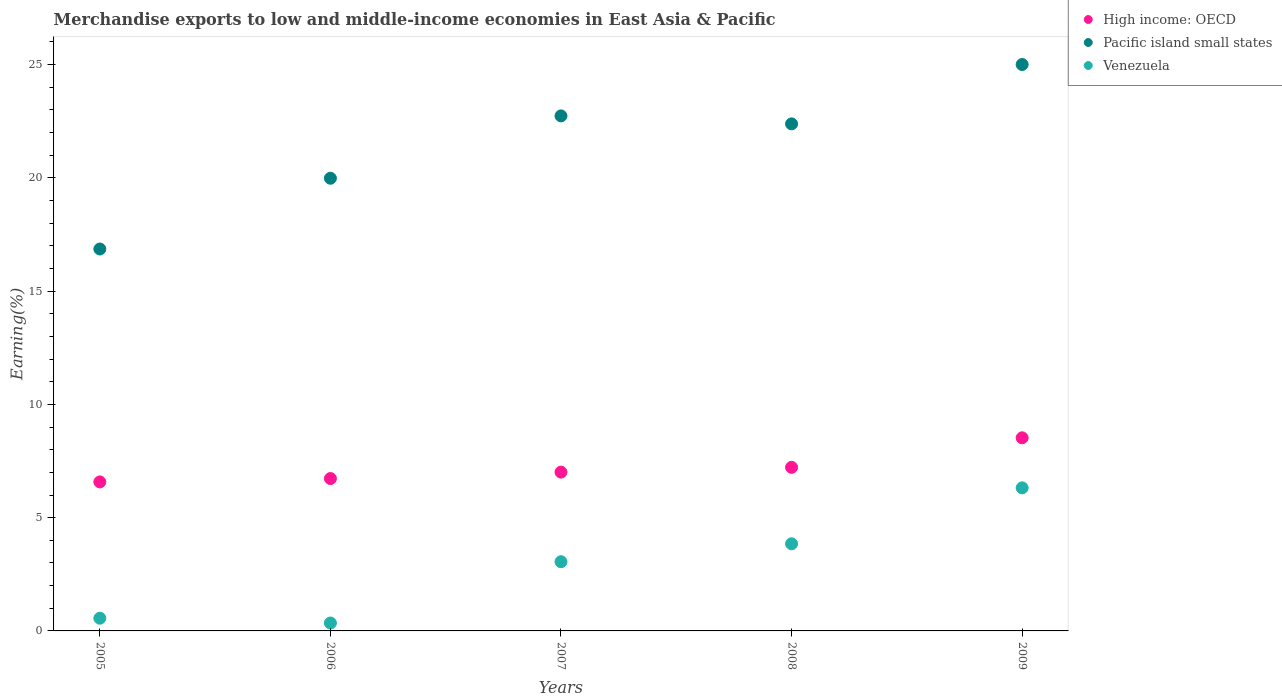Is the number of dotlines equal to the number of legend labels?
Provide a short and direct response. Yes. What is the percentage of amount earned from merchandise exports in Pacific island small states in 2006?
Keep it short and to the point. 19.98. Across all years, what is the maximum percentage of amount earned from merchandise exports in Venezuela?
Offer a very short reply. 6.32. Across all years, what is the minimum percentage of amount earned from merchandise exports in Venezuela?
Provide a short and direct response. 0.35. In which year was the percentage of amount earned from merchandise exports in Pacific island small states minimum?
Give a very brief answer. 2005. What is the total percentage of amount earned from merchandise exports in Pacific island small states in the graph?
Offer a terse response. 106.97. What is the difference between the percentage of amount earned from merchandise exports in High income: OECD in 2005 and that in 2006?
Offer a terse response. -0.15. What is the difference between the percentage of amount earned from merchandise exports in Venezuela in 2006 and the percentage of amount earned from merchandise exports in High income: OECD in 2005?
Provide a succinct answer. -6.23. What is the average percentage of amount earned from merchandise exports in Pacific island small states per year?
Ensure brevity in your answer.  21.39. In the year 2008, what is the difference between the percentage of amount earned from merchandise exports in High income: OECD and percentage of amount earned from merchandise exports in Venezuela?
Your answer should be very brief. 3.38. What is the ratio of the percentage of amount earned from merchandise exports in Pacific island small states in 2007 to that in 2008?
Your answer should be compact. 1.02. Is the difference between the percentage of amount earned from merchandise exports in High income: OECD in 2006 and 2008 greater than the difference between the percentage of amount earned from merchandise exports in Venezuela in 2006 and 2008?
Provide a succinct answer. Yes. What is the difference between the highest and the second highest percentage of amount earned from merchandise exports in Pacific island small states?
Ensure brevity in your answer.  2.27. What is the difference between the highest and the lowest percentage of amount earned from merchandise exports in Venezuela?
Ensure brevity in your answer.  5.97. Is the sum of the percentage of amount earned from merchandise exports in Pacific island small states in 2007 and 2009 greater than the maximum percentage of amount earned from merchandise exports in Venezuela across all years?
Your response must be concise. Yes. Is it the case that in every year, the sum of the percentage of amount earned from merchandise exports in Pacific island small states and percentage of amount earned from merchandise exports in Venezuela  is greater than the percentage of amount earned from merchandise exports in High income: OECD?
Offer a very short reply. Yes. Does the percentage of amount earned from merchandise exports in Pacific island small states monotonically increase over the years?
Ensure brevity in your answer.  No. How many dotlines are there?
Make the answer very short. 3. Are the values on the major ticks of Y-axis written in scientific E-notation?
Your response must be concise. No. Does the graph contain any zero values?
Provide a short and direct response. No. Where does the legend appear in the graph?
Give a very brief answer. Top right. How many legend labels are there?
Your response must be concise. 3. How are the legend labels stacked?
Your answer should be very brief. Vertical. What is the title of the graph?
Your answer should be very brief. Merchandise exports to low and middle-income economies in East Asia & Pacific. What is the label or title of the Y-axis?
Offer a terse response. Earning(%). What is the Earning(%) in High income: OECD in 2005?
Give a very brief answer. 6.58. What is the Earning(%) in Pacific island small states in 2005?
Offer a terse response. 16.86. What is the Earning(%) of Venezuela in 2005?
Ensure brevity in your answer.  0.56. What is the Earning(%) of High income: OECD in 2006?
Your answer should be compact. 6.73. What is the Earning(%) of Pacific island small states in 2006?
Provide a succinct answer. 19.98. What is the Earning(%) of Venezuela in 2006?
Provide a short and direct response. 0.35. What is the Earning(%) of High income: OECD in 2007?
Give a very brief answer. 7.01. What is the Earning(%) in Pacific island small states in 2007?
Keep it short and to the point. 22.74. What is the Earning(%) in Venezuela in 2007?
Your response must be concise. 3.06. What is the Earning(%) in High income: OECD in 2008?
Your response must be concise. 7.22. What is the Earning(%) in Pacific island small states in 2008?
Your answer should be compact. 22.39. What is the Earning(%) of Venezuela in 2008?
Give a very brief answer. 3.85. What is the Earning(%) in High income: OECD in 2009?
Ensure brevity in your answer.  8.53. What is the Earning(%) in Pacific island small states in 2009?
Your answer should be very brief. 25.01. What is the Earning(%) in Venezuela in 2009?
Offer a terse response. 6.32. Across all years, what is the maximum Earning(%) of High income: OECD?
Provide a succinct answer. 8.53. Across all years, what is the maximum Earning(%) of Pacific island small states?
Your response must be concise. 25.01. Across all years, what is the maximum Earning(%) of Venezuela?
Ensure brevity in your answer.  6.32. Across all years, what is the minimum Earning(%) in High income: OECD?
Offer a very short reply. 6.58. Across all years, what is the minimum Earning(%) of Pacific island small states?
Provide a short and direct response. 16.86. Across all years, what is the minimum Earning(%) of Venezuela?
Ensure brevity in your answer.  0.35. What is the total Earning(%) of High income: OECD in the graph?
Offer a terse response. 36.07. What is the total Earning(%) of Pacific island small states in the graph?
Offer a very short reply. 106.97. What is the total Earning(%) in Venezuela in the graph?
Provide a short and direct response. 14.13. What is the difference between the Earning(%) of High income: OECD in 2005 and that in 2006?
Your answer should be compact. -0.15. What is the difference between the Earning(%) in Pacific island small states in 2005 and that in 2006?
Your answer should be very brief. -3.12. What is the difference between the Earning(%) in Venezuela in 2005 and that in 2006?
Ensure brevity in your answer.  0.21. What is the difference between the Earning(%) in High income: OECD in 2005 and that in 2007?
Keep it short and to the point. -0.43. What is the difference between the Earning(%) in Pacific island small states in 2005 and that in 2007?
Provide a succinct answer. -5.88. What is the difference between the Earning(%) in Venezuela in 2005 and that in 2007?
Ensure brevity in your answer.  -2.49. What is the difference between the Earning(%) of High income: OECD in 2005 and that in 2008?
Keep it short and to the point. -0.64. What is the difference between the Earning(%) of Pacific island small states in 2005 and that in 2008?
Your answer should be compact. -5.52. What is the difference between the Earning(%) in Venezuela in 2005 and that in 2008?
Provide a short and direct response. -3.29. What is the difference between the Earning(%) in High income: OECD in 2005 and that in 2009?
Offer a terse response. -1.95. What is the difference between the Earning(%) in Pacific island small states in 2005 and that in 2009?
Ensure brevity in your answer.  -8.14. What is the difference between the Earning(%) of Venezuela in 2005 and that in 2009?
Make the answer very short. -5.75. What is the difference between the Earning(%) of High income: OECD in 2006 and that in 2007?
Make the answer very short. -0.28. What is the difference between the Earning(%) in Pacific island small states in 2006 and that in 2007?
Your answer should be compact. -2.75. What is the difference between the Earning(%) of Venezuela in 2006 and that in 2007?
Your answer should be compact. -2.71. What is the difference between the Earning(%) of High income: OECD in 2006 and that in 2008?
Offer a terse response. -0.5. What is the difference between the Earning(%) of Pacific island small states in 2006 and that in 2008?
Offer a terse response. -2.4. What is the difference between the Earning(%) in Venezuela in 2006 and that in 2008?
Make the answer very short. -3.5. What is the difference between the Earning(%) of High income: OECD in 2006 and that in 2009?
Make the answer very short. -1.8. What is the difference between the Earning(%) of Pacific island small states in 2006 and that in 2009?
Offer a very short reply. -5.02. What is the difference between the Earning(%) in Venezuela in 2006 and that in 2009?
Ensure brevity in your answer.  -5.97. What is the difference between the Earning(%) in High income: OECD in 2007 and that in 2008?
Your answer should be compact. -0.21. What is the difference between the Earning(%) of Pacific island small states in 2007 and that in 2008?
Offer a terse response. 0.35. What is the difference between the Earning(%) of Venezuela in 2007 and that in 2008?
Your answer should be very brief. -0.79. What is the difference between the Earning(%) of High income: OECD in 2007 and that in 2009?
Provide a short and direct response. -1.52. What is the difference between the Earning(%) in Pacific island small states in 2007 and that in 2009?
Make the answer very short. -2.27. What is the difference between the Earning(%) of Venezuela in 2007 and that in 2009?
Your response must be concise. -3.26. What is the difference between the Earning(%) of High income: OECD in 2008 and that in 2009?
Give a very brief answer. -1.3. What is the difference between the Earning(%) in Pacific island small states in 2008 and that in 2009?
Offer a very short reply. -2.62. What is the difference between the Earning(%) of Venezuela in 2008 and that in 2009?
Provide a succinct answer. -2.47. What is the difference between the Earning(%) in High income: OECD in 2005 and the Earning(%) in Pacific island small states in 2006?
Offer a very short reply. -13.41. What is the difference between the Earning(%) in High income: OECD in 2005 and the Earning(%) in Venezuela in 2006?
Keep it short and to the point. 6.23. What is the difference between the Earning(%) in Pacific island small states in 2005 and the Earning(%) in Venezuela in 2006?
Make the answer very short. 16.51. What is the difference between the Earning(%) in High income: OECD in 2005 and the Earning(%) in Pacific island small states in 2007?
Ensure brevity in your answer.  -16.16. What is the difference between the Earning(%) in High income: OECD in 2005 and the Earning(%) in Venezuela in 2007?
Your answer should be compact. 3.52. What is the difference between the Earning(%) in Pacific island small states in 2005 and the Earning(%) in Venezuela in 2007?
Your answer should be compact. 13.81. What is the difference between the Earning(%) in High income: OECD in 2005 and the Earning(%) in Pacific island small states in 2008?
Your response must be concise. -15.81. What is the difference between the Earning(%) of High income: OECD in 2005 and the Earning(%) of Venezuela in 2008?
Provide a succinct answer. 2.73. What is the difference between the Earning(%) in Pacific island small states in 2005 and the Earning(%) in Venezuela in 2008?
Offer a terse response. 13.01. What is the difference between the Earning(%) of High income: OECD in 2005 and the Earning(%) of Pacific island small states in 2009?
Provide a short and direct response. -18.43. What is the difference between the Earning(%) of High income: OECD in 2005 and the Earning(%) of Venezuela in 2009?
Your answer should be very brief. 0.26. What is the difference between the Earning(%) in Pacific island small states in 2005 and the Earning(%) in Venezuela in 2009?
Your answer should be compact. 10.55. What is the difference between the Earning(%) in High income: OECD in 2006 and the Earning(%) in Pacific island small states in 2007?
Give a very brief answer. -16.01. What is the difference between the Earning(%) in High income: OECD in 2006 and the Earning(%) in Venezuela in 2007?
Your answer should be compact. 3.67. What is the difference between the Earning(%) in Pacific island small states in 2006 and the Earning(%) in Venezuela in 2007?
Make the answer very short. 16.93. What is the difference between the Earning(%) in High income: OECD in 2006 and the Earning(%) in Pacific island small states in 2008?
Your answer should be very brief. -15.66. What is the difference between the Earning(%) of High income: OECD in 2006 and the Earning(%) of Venezuela in 2008?
Your response must be concise. 2.88. What is the difference between the Earning(%) of Pacific island small states in 2006 and the Earning(%) of Venezuela in 2008?
Your answer should be compact. 16.14. What is the difference between the Earning(%) in High income: OECD in 2006 and the Earning(%) in Pacific island small states in 2009?
Offer a terse response. -18.28. What is the difference between the Earning(%) in High income: OECD in 2006 and the Earning(%) in Venezuela in 2009?
Your response must be concise. 0.41. What is the difference between the Earning(%) in Pacific island small states in 2006 and the Earning(%) in Venezuela in 2009?
Your response must be concise. 13.67. What is the difference between the Earning(%) of High income: OECD in 2007 and the Earning(%) of Pacific island small states in 2008?
Your response must be concise. -15.37. What is the difference between the Earning(%) of High income: OECD in 2007 and the Earning(%) of Venezuela in 2008?
Offer a very short reply. 3.16. What is the difference between the Earning(%) in Pacific island small states in 2007 and the Earning(%) in Venezuela in 2008?
Your answer should be compact. 18.89. What is the difference between the Earning(%) in High income: OECD in 2007 and the Earning(%) in Pacific island small states in 2009?
Your answer should be very brief. -18. What is the difference between the Earning(%) in High income: OECD in 2007 and the Earning(%) in Venezuela in 2009?
Your response must be concise. 0.69. What is the difference between the Earning(%) of Pacific island small states in 2007 and the Earning(%) of Venezuela in 2009?
Your answer should be very brief. 16.42. What is the difference between the Earning(%) in High income: OECD in 2008 and the Earning(%) in Pacific island small states in 2009?
Give a very brief answer. -17.78. What is the difference between the Earning(%) in High income: OECD in 2008 and the Earning(%) in Venezuela in 2009?
Ensure brevity in your answer.  0.91. What is the difference between the Earning(%) of Pacific island small states in 2008 and the Earning(%) of Venezuela in 2009?
Your response must be concise. 16.07. What is the average Earning(%) of High income: OECD per year?
Your answer should be compact. 7.21. What is the average Earning(%) in Pacific island small states per year?
Give a very brief answer. 21.39. What is the average Earning(%) in Venezuela per year?
Provide a short and direct response. 2.83. In the year 2005, what is the difference between the Earning(%) of High income: OECD and Earning(%) of Pacific island small states?
Offer a terse response. -10.28. In the year 2005, what is the difference between the Earning(%) in High income: OECD and Earning(%) in Venezuela?
Offer a very short reply. 6.02. In the year 2005, what is the difference between the Earning(%) in Pacific island small states and Earning(%) in Venezuela?
Offer a very short reply. 16.3. In the year 2006, what is the difference between the Earning(%) in High income: OECD and Earning(%) in Pacific island small states?
Your answer should be compact. -13.26. In the year 2006, what is the difference between the Earning(%) of High income: OECD and Earning(%) of Venezuela?
Provide a short and direct response. 6.38. In the year 2006, what is the difference between the Earning(%) of Pacific island small states and Earning(%) of Venezuela?
Provide a succinct answer. 19.64. In the year 2007, what is the difference between the Earning(%) of High income: OECD and Earning(%) of Pacific island small states?
Your answer should be very brief. -15.73. In the year 2007, what is the difference between the Earning(%) in High income: OECD and Earning(%) in Venezuela?
Provide a short and direct response. 3.96. In the year 2007, what is the difference between the Earning(%) in Pacific island small states and Earning(%) in Venezuela?
Your answer should be compact. 19.68. In the year 2008, what is the difference between the Earning(%) in High income: OECD and Earning(%) in Pacific island small states?
Keep it short and to the point. -15.16. In the year 2008, what is the difference between the Earning(%) of High income: OECD and Earning(%) of Venezuela?
Ensure brevity in your answer.  3.38. In the year 2008, what is the difference between the Earning(%) of Pacific island small states and Earning(%) of Venezuela?
Make the answer very short. 18.54. In the year 2009, what is the difference between the Earning(%) of High income: OECD and Earning(%) of Pacific island small states?
Your response must be concise. -16.48. In the year 2009, what is the difference between the Earning(%) in High income: OECD and Earning(%) in Venezuela?
Ensure brevity in your answer.  2.21. In the year 2009, what is the difference between the Earning(%) in Pacific island small states and Earning(%) in Venezuela?
Provide a succinct answer. 18.69. What is the ratio of the Earning(%) in High income: OECD in 2005 to that in 2006?
Your response must be concise. 0.98. What is the ratio of the Earning(%) of Pacific island small states in 2005 to that in 2006?
Provide a short and direct response. 0.84. What is the ratio of the Earning(%) in Venezuela in 2005 to that in 2006?
Give a very brief answer. 1.61. What is the ratio of the Earning(%) in High income: OECD in 2005 to that in 2007?
Your answer should be compact. 0.94. What is the ratio of the Earning(%) in Pacific island small states in 2005 to that in 2007?
Your answer should be compact. 0.74. What is the ratio of the Earning(%) of Venezuela in 2005 to that in 2007?
Your response must be concise. 0.18. What is the ratio of the Earning(%) in High income: OECD in 2005 to that in 2008?
Ensure brevity in your answer.  0.91. What is the ratio of the Earning(%) in Pacific island small states in 2005 to that in 2008?
Provide a short and direct response. 0.75. What is the ratio of the Earning(%) of Venezuela in 2005 to that in 2008?
Provide a succinct answer. 0.15. What is the ratio of the Earning(%) in High income: OECD in 2005 to that in 2009?
Offer a very short reply. 0.77. What is the ratio of the Earning(%) of Pacific island small states in 2005 to that in 2009?
Keep it short and to the point. 0.67. What is the ratio of the Earning(%) in Venezuela in 2005 to that in 2009?
Provide a succinct answer. 0.09. What is the ratio of the Earning(%) of High income: OECD in 2006 to that in 2007?
Make the answer very short. 0.96. What is the ratio of the Earning(%) in Pacific island small states in 2006 to that in 2007?
Your response must be concise. 0.88. What is the ratio of the Earning(%) in Venezuela in 2006 to that in 2007?
Give a very brief answer. 0.11. What is the ratio of the Earning(%) of High income: OECD in 2006 to that in 2008?
Make the answer very short. 0.93. What is the ratio of the Earning(%) of Pacific island small states in 2006 to that in 2008?
Ensure brevity in your answer.  0.89. What is the ratio of the Earning(%) in Venezuela in 2006 to that in 2008?
Your answer should be very brief. 0.09. What is the ratio of the Earning(%) in High income: OECD in 2006 to that in 2009?
Your answer should be compact. 0.79. What is the ratio of the Earning(%) of Pacific island small states in 2006 to that in 2009?
Your answer should be very brief. 0.8. What is the ratio of the Earning(%) in Venezuela in 2006 to that in 2009?
Offer a terse response. 0.06. What is the ratio of the Earning(%) of High income: OECD in 2007 to that in 2008?
Your response must be concise. 0.97. What is the ratio of the Earning(%) in Pacific island small states in 2007 to that in 2008?
Keep it short and to the point. 1.02. What is the ratio of the Earning(%) of Venezuela in 2007 to that in 2008?
Offer a terse response. 0.79. What is the ratio of the Earning(%) of High income: OECD in 2007 to that in 2009?
Your answer should be very brief. 0.82. What is the ratio of the Earning(%) in Pacific island small states in 2007 to that in 2009?
Make the answer very short. 0.91. What is the ratio of the Earning(%) of Venezuela in 2007 to that in 2009?
Offer a very short reply. 0.48. What is the ratio of the Earning(%) in High income: OECD in 2008 to that in 2009?
Make the answer very short. 0.85. What is the ratio of the Earning(%) in Pacific island small states in 2008 to that in 2009?
Provide a succinct answer. 0.9. What is the ratio of the Earning(%) in Venezuela in 2008 to that in 2009?
Give a very brief answer. 0.61. What is the difference between the highest and the second highest Earning(%) of High income: OECD?
Provide a short and direct response. 1.3. What is the difference between the highest and the second highest Earning(%) of Pacific island small states?
Provide a succinct answer. 2.27. What is the difference between the highest and the second highest Earning(%) of Venezuela?
Your answer should be very brief. 2.47. What is the difference between the highest and the lowest Earning(%) in High income: OECD?
Keep it short and to the point. 1.95. What is the difference between the highest and the lowest Earning(%) in Pacific island small states?
Offer a terse response. 8.14. What is the difference between the highest and the lowest Earning(%) in Venezuela?
Give a very brief answer. 5.97. 